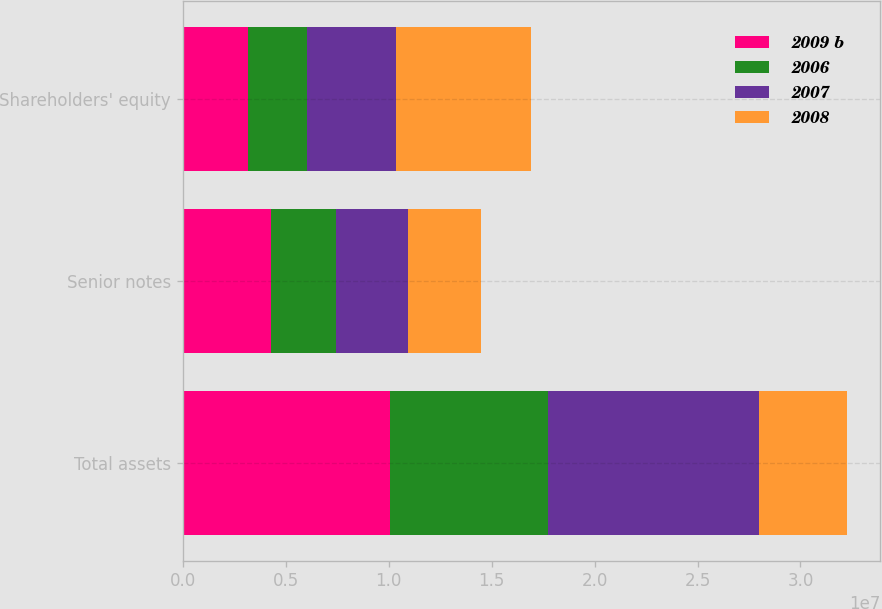Convert chart to OTSL. <chart><loc_0><loc_0><loc_500><loc_500><stacked_bar_chart><ecel><fcel>Total assets<fcel>Senior notes<fcel>Shareholders' equity<nl><fcel>2009 b<fcel>1.00512e+07<fcel>4.28153e+06<fcel>3.19444e+06<nl><fcel>2006<fcel>7.70846e+06<fcel>3.1663e+06<fcel>2.8357e+06<nl><fcel>2007<fcel>1.02257e+07<fcel>3.47823e+06<fcel>4.32019e+06<nl><fcel>2008<fcel>4.28153e+06<fcel>3.53795e+06<fcel>6.57736e+06<nl></chart> 